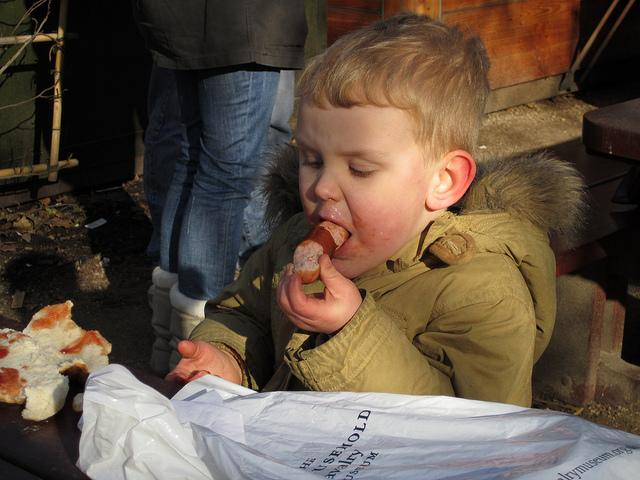Why is the food eaten by the boy unhealthy?

Choices:
A) high sodium
B) high carbohydrate
C) high fat
D) high sugar high sodium 